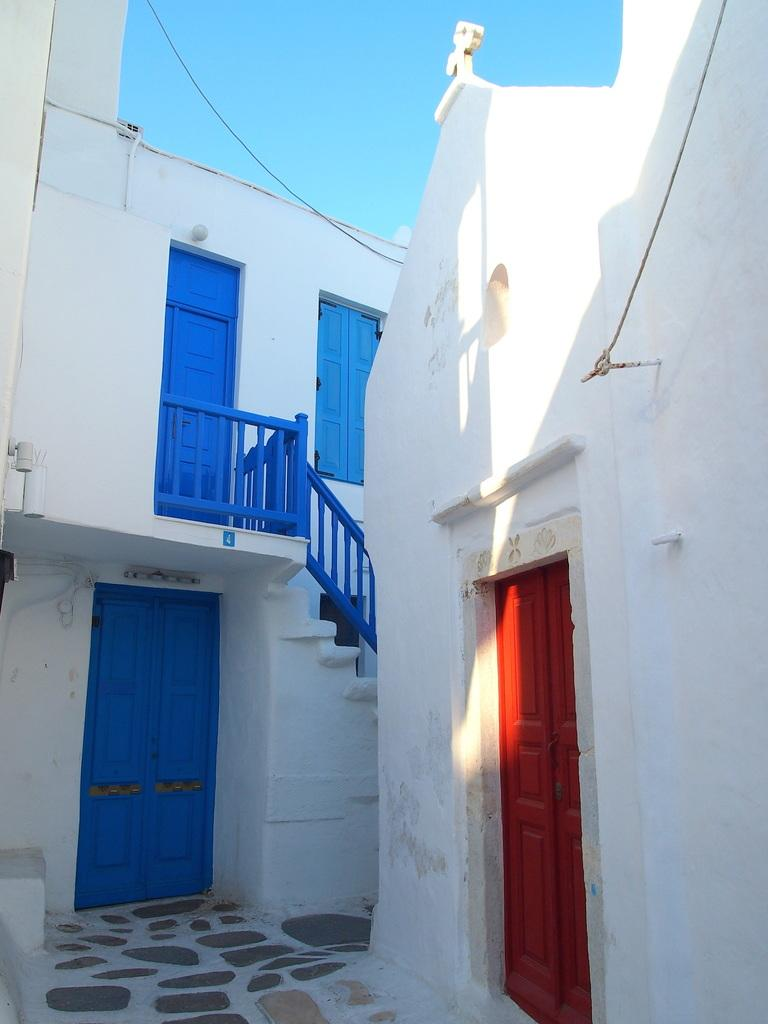What type of structures are present in the image? There are buildings in the image. What features do the buildings have? The buildings have doors, staircases, and windows. What is visible at the top of the image? The sky is visible at the top of the image. Can you tell me how many goats are standing on the roof of the building in the image? There are no goats present in the image; it only features buildings with doors, staircases, and windows. 